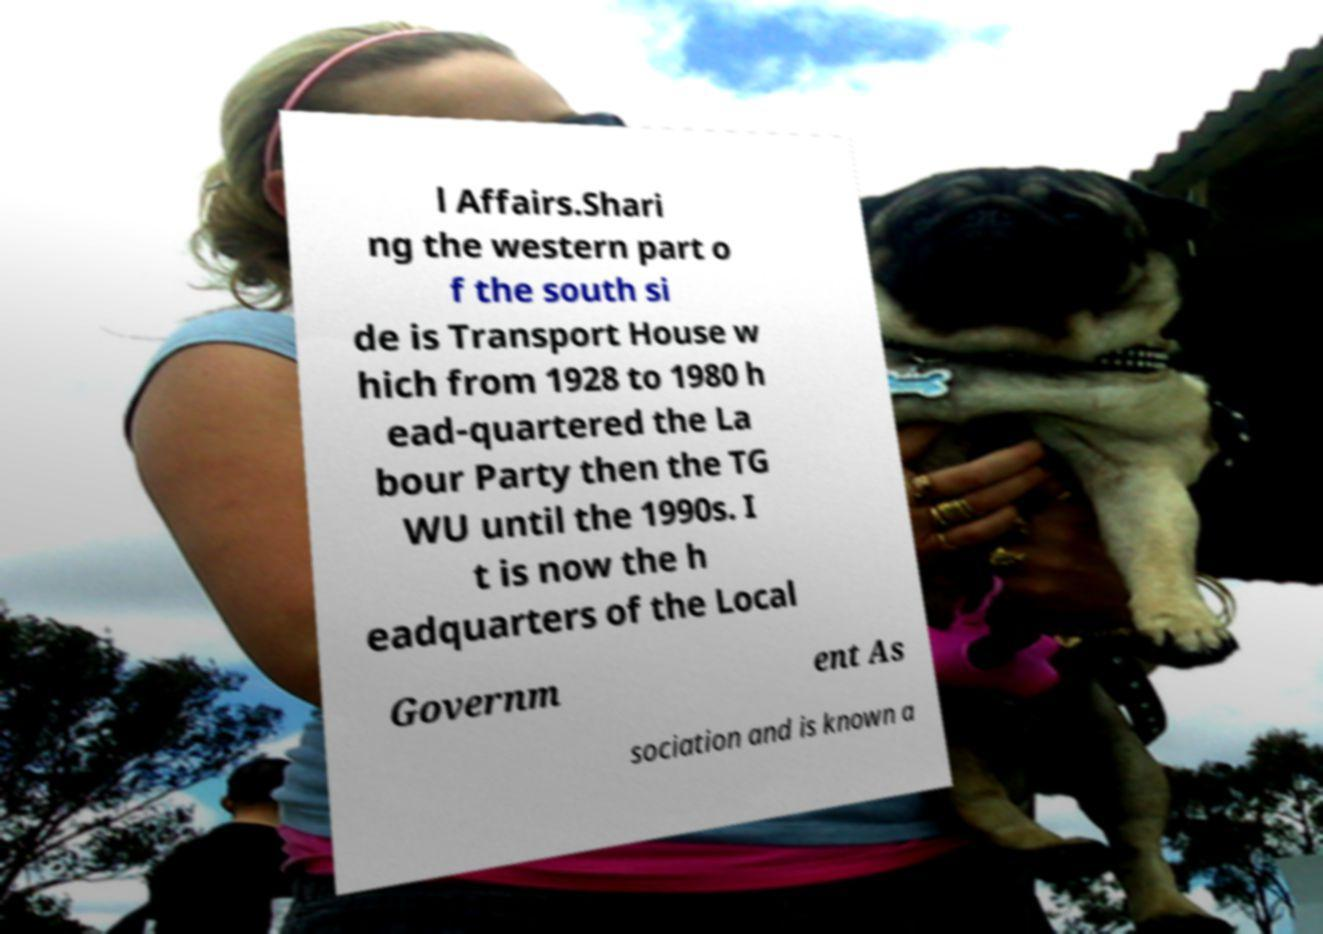Can you read and provide the text displayed in the image?This photo seems to have some interesting text. Can you extract and type it out for me? l Affairs.Shari ng the western part o f the south si de is Transport House w hich from 1928 to 1980 h ead-quartered the La bour Party then the TG WU until the 1990s. I t is now the h eadquarters of the Local Governm ent As sociation and is known a 